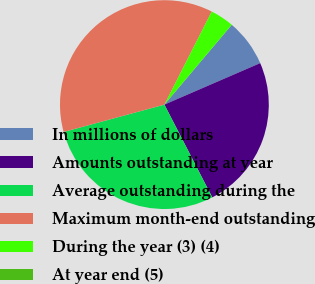<chart> <loc_0><loc_0><loc_500><loc_500><pie_chart><fcel>In millions of dollars<fcel>Amounts outstanding at year<fcel>Average outstanding during the<fcel>Maximum month-end outstanding<fcel>During the year (3) (4)<fcel>At year end (5)<nl><fcel>7.34%<fcel>23.92%<fcel>28.36%<fcel>36.7%<fcel>3.67%<fcel>0.0%<nl></chart> 